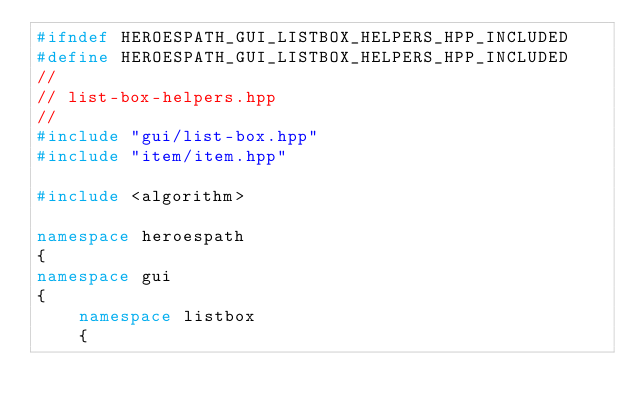<code> <loc_0><loc_0><loc_500><loc_500><_C++_>#ifndef HEROESPATH_GUI_LISTBOX_HELPERS_HPP_INCLUDED
#define HEROESPATH_GUI_LISTBOX_HELPERS_HPP_INCLUDED
//
// list-box-helpers.hpp
//
#include "gui/list-box.hpp"
#include "item/item.hpp"

#include <algorithm>

namespace heroespath
{
namespace gui
{
    namespace listbox
    {
</code> 